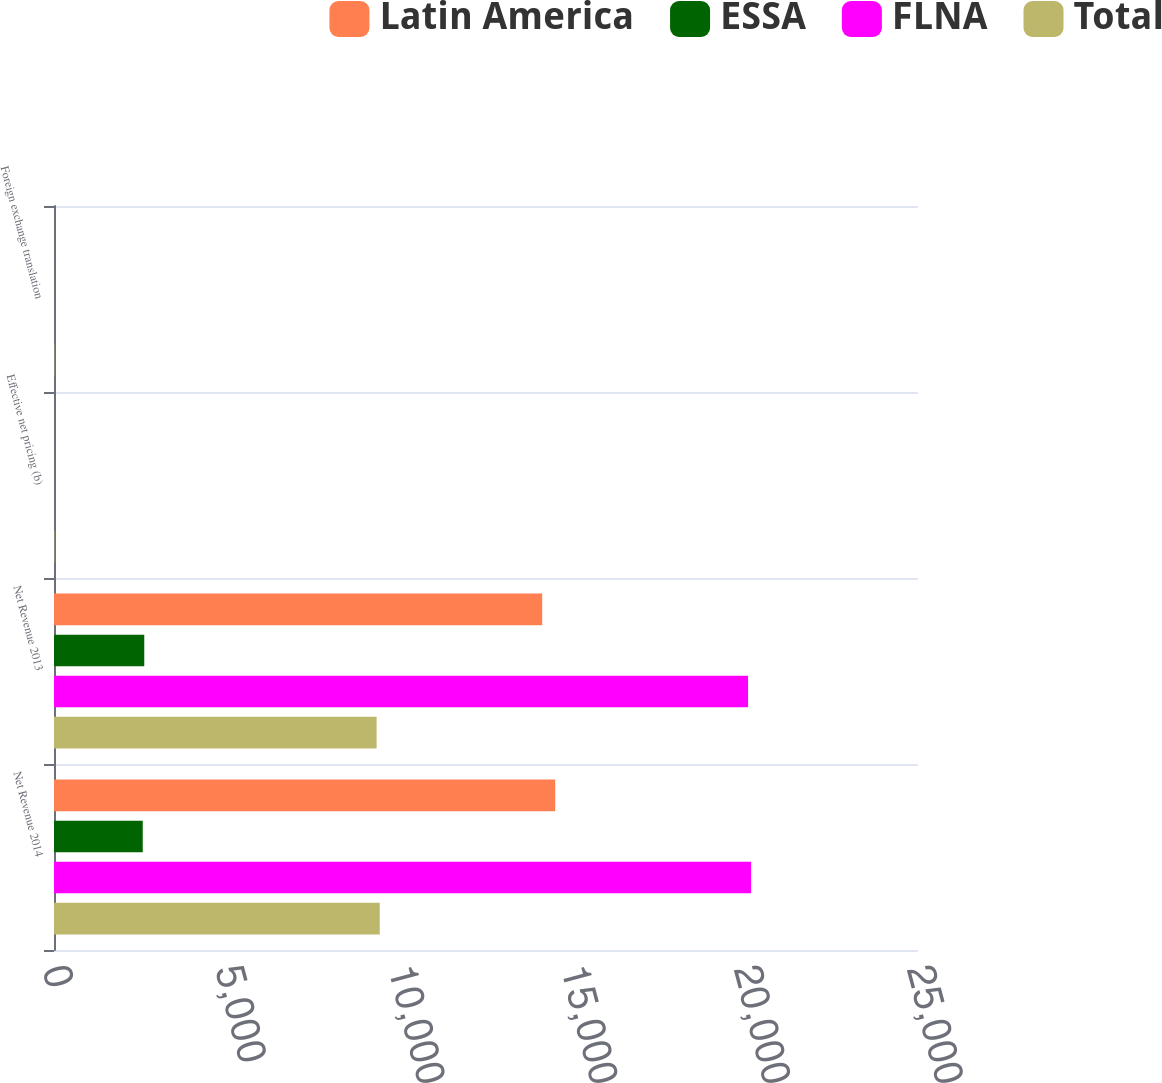<chart> <loc_0><loc_0><loc_500><loc_500><stacked_bar_chart><ecel><fcel>Net Revenue 2014<fcel>Net Revenue 2013<fcel>Effective net pricing (b)<fcel>Foreign exchange translation<nl><fcel>Latin America<fcel>14502<fcel>14126<fcel>1<fcel>1<nl><fcel>ESSA<fcel>2568<fcel>2612<fcel>1<fcel>1<nl><fcel>FLNA<fcel>20171<fcel>20083<fcel>1<fcel>0.5<nl><fcel>Total<fcel>9425<fcel>9335<fcel>11<fcel>9<nl></chart> 